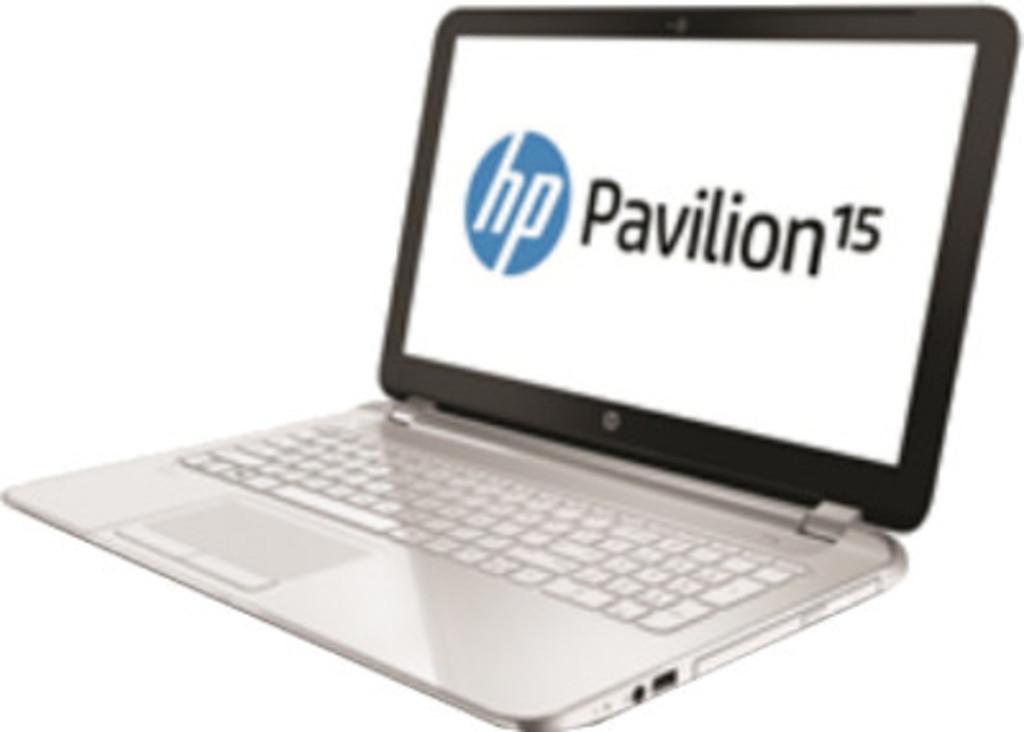Who makes this laptop?
Ensure brevity in your answer.  Hp. What number is shown on the screen?
Offer a terse response. 15. 